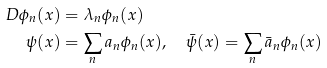<formula> <loc_0><loc_0><loc_500><loc_500>\ D \phi _ { n } ( x ) & = \lambda _ { n } \phi _ { n } ( x ) \\ \psi ( x ) & = \sum _ { n } a _ { n } \phi _ { n } ( x ) , \quad \bar { \psi } ( x ) = \sum _ { n } \bar { a } _ { n } \phi _ { n } ( x )</formula> 